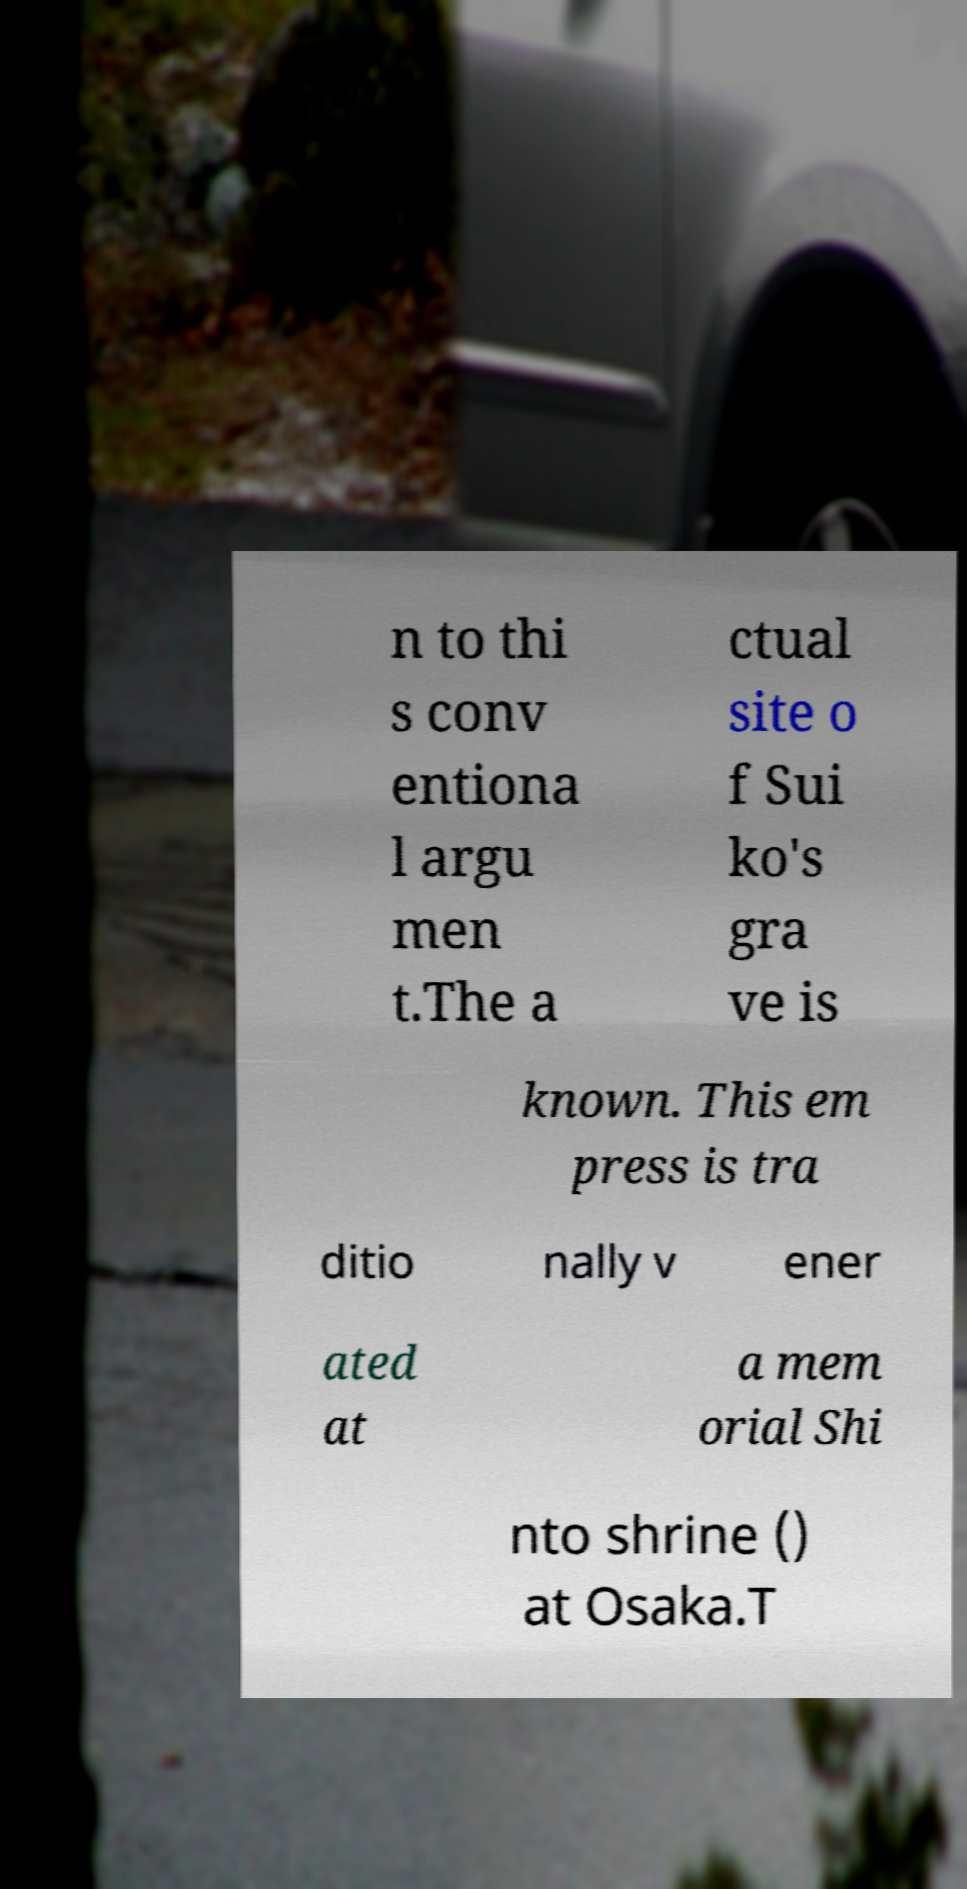What messages or text are displayed in this image? I need them in a readable, typed format. n to thi s conv entiona l argu men t.The a ctual site o f Sui ko's gra ve is known. This em press is tra ditio nally v ener ated at a mem orial Shi nto shrine () at Osaka.T 